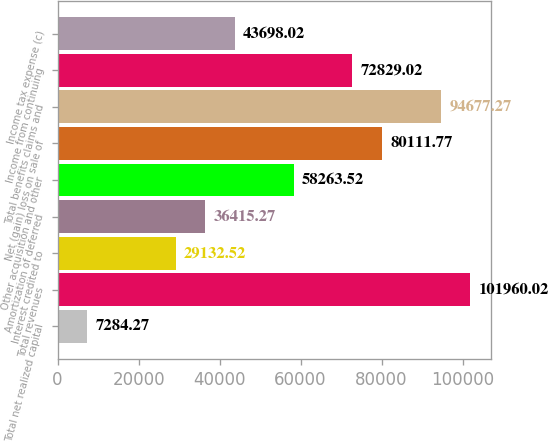<chart> <loc_0><loc_0><loc_500><loc_500><bar_chart><fcel>Total net realized capital<fcel>Total revenues<fcel>Interest credited to<fcel>Amortization of deferred<fcel>Other acquisition and other<fcel>Net (gain) loss on sale of<fcel>Total benefits claims and<fcel>Income from continuing<fcel>Income tax expense (c)<nl><fcel>7284.27<fcel>101960<fcel>29132.5<fcel>36415.3<fcel>58263.5<fcel>80111.8<fcel>94677.3<fcel>72829<fcel>43698<nl></chart> 